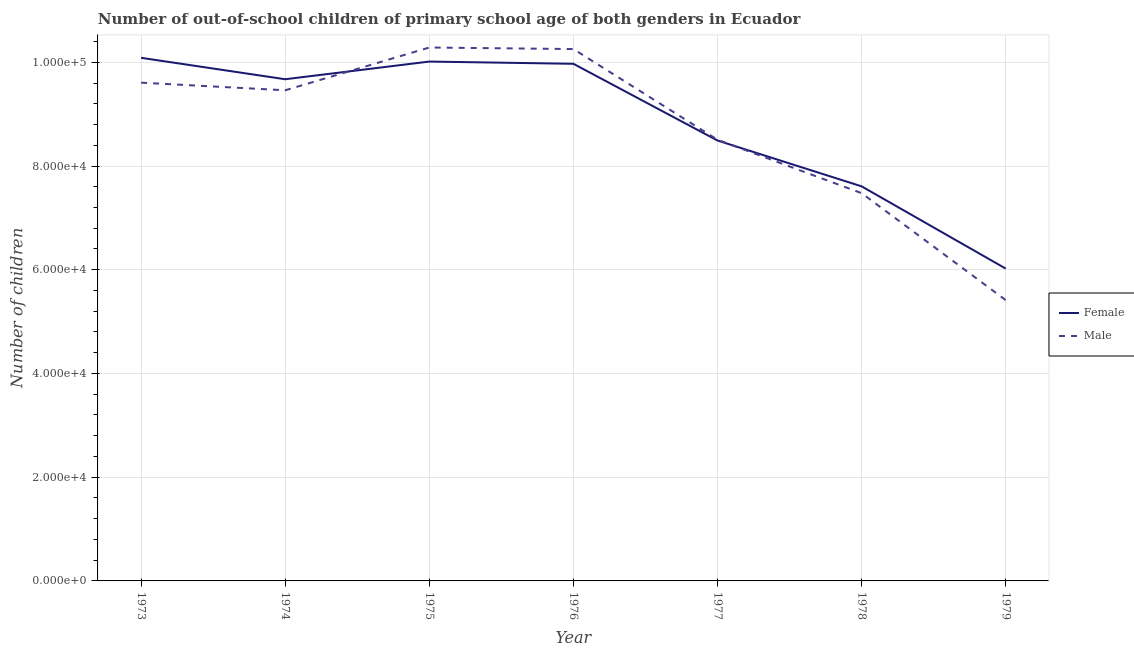Does the line corresponding to number of male out-of-school students intersect with the line corresponding to number of female out-of-school students?
Keep it short and to the point. Yes. What is the number of male out-of-school students in 1974?
Your answer should be very brief. 9.46e+04. Across all years, what is the maximum number of female out-of-school students?
Offer a terse response. 1.01e+05. Across all years, what is the minimum number of male out-of-school students?
Your answer should be compact. 5.41e+04. In which year was the number of female out-of-school students minimum?
Your answer should be very brief. 1979. What is the total number of male out-of-school students in the graph?
Your response must be concise. 6.10e+05. What is the difference between the number of female out-of-school students in 1974 and that in 1975?
Ensure brevity in your answer.  -3409. What is the difference between the number of female out-of-school students in 1974 and the number of male out-of-school students in 1973?
Your response must be concise. 659. What is the average number of male out-of-school students per year?
Offer a very short reply. 8.71e+04. In the year 1975, what is the difference between the number of male out-of-school students and number of female out-of-school students?
Keep it short and to the point. 2709. What is the ratio of the number of female out-of-school students in 1974 to that in 1976?
Offer a terse response. 0.97. What is the difference between the highest and the second highest number of female out-of-school students?
Offer a terse response. 721. What is the difference between the highest and the lowest number of male out-of-school students?
Give a very brief answer. 4.87e+04. Is the sum of the number of female out-of-school students in 1976 and 1977 greater than the maximum number of male out-of-school students across all years?
Ensure brevity in your answer.  Yes. Is the number of female out-of-school students strictly greater than the number of male out-of-school students over the years?
Offer a very short reply. No. Is the number of female out-of-school students strictly less than the number of male out-of-school students over the years?
Your response must be concise. No. How many years are there in the graph?
Keep it short and to the point. 7. What is the difference between two consecutive major ticks on the Y-axis?
Make the answer very short. 2.00e+04. Does the graph contain grids?
Offer a terse response. Yes. Where does the legend appear in the graph?
Keep it short and to the point. Center right. How many legend labels are there?
Keep it short and to the point. 2. What is the title of the graph?
Offer a very short reply. Number of out-of-school children of primary school age of both genders in Ecuador. What is the label or title of the X-axis?
Ensure brevity in your answer.  Year. What is the label or title of the Y-axis?
Offer a terse response. Number of children. What is the Number of children of Female in 1973?
Provide a succinct answer. 1.01e+05. What is the Number of children in Male in 1973?
Ensure brevity in your answer.  9.61e+04. What is the Number of children in Female in 1974?
Offer a very short reply. 9.67e+04. What is the Number of children in Male in 1974?
Offer a terse response. 9.46e+04. What is the Number of children in Female in 1975?
Provide a short and direct response. 1.00e+05. What is the Number of children of Male in 1975?
Keep it short and to the point. 1.03e+05. What is the Number of children in Female in 1976?
Provide a succinct answer. 9.97e+04. What is the Number of children of Male in 1976?
Provide a succinct answer. 1.03e+05. What is the Number of children of Female in 1977?
Provide a succinct answer. 8.49e+04. What is the Number of children in Male in 1977?
Make the answer very short. 8.51e+04. What is the Number of children of Female in 1978?
Provide a succinct answer. 7.61e+04. What is the Number of children in Male in 1978?
Offer a very short reply. 7.48e+04. What is the Number of children in Female in 1979?
Make the answer very short. 6.02e+04. What is the Number of children of Male in 1979?
Your response must be concise. 5.41e+04. Across all years, what is the maximum Number of children in Female?
Ensure brevity in your answer.  1.01e+05. Across all years, what is the maximum Number of children of Male?
Keep it short and to the point. 1.03e+05. Across all years, what is the minimum Number of children in Female?
Your response must be concise. 6.02e+04. Across all years, what is the minimum Number of children in Male?
Make the answer very short. 5.41e+04. What is the total Number of children of Female in the graph?
Provide a succinct answer. 6.19e+05. What is the total Number of children of Male in the graph?
Your response must be concise. 6.10e+05. What is the difference between the Number of children in Female in 1973 and that in 1974?
Offer a terse response. 4130. What is the difference between the Number of children in Male in 1973 and that in 1974?
Your response must be concise. 1470. What is the difference between the Number of children in Female in 1973 and that in 1975?
Keep it short and to the point. 721. What is the difference between the Number of children of Male in 1973 and that in 1975?
Ensure brevity in your answer.  -6777. What is the difference between the Number of children in Female in 1973 and that in 1976?
Make the answer very short. 1154. What is the difference between the Number of children of Male in 1973 and that in 1976?
Your answer should be very brief. -6476. What is the difference between the Number of children in Female in 1973 and that in 1977?
Your response must be concise. 1.60e+04. What is the difference between the Number of children of Male in 1973 and that in 1977?
Offer a terse response. 1.10e+04. What is the difference between the Number of children of Female in 1973 and that in 1978?
Your answer should be very brief. 2.48e+04. What is the difference between the Number of children of Male in 1973 and that in 1978?
Provide a short and direct response. 2.13e+04. What is the difference between the Number of children of Female in 1973 and that in 1979?
Your answer should be compact. 4.06e+04. What is the difference between the Number of children in Male in 1973 and that in 1979?
Provide a succinct answer. 4.19e+04. What is the difference between the Number of children of Female in 1974 and that in 1975?
Offer a terse response. -3409. What is the difference between the Number of children of Male in 1974 and that in 1975?
Ensure brevity in your answer.  -8247. What is the difference between the Number of children in Female in 1974 and that in 1976?
Your response must be concise. -2976. What is the difference between the Number of children in Male in 1974 and that in 1976?
Provide a short and direct response. -7946. What is the difference between the Number of children in Female in 1974 and that in 1977?
Give a very brief answer. 1.18e+04. What is the difference between the Number of children of Male in 1974 and that in 1977?
Make the answer very short. 9545. What is the difference between the Number of children in Female in 1974 and that in 1978?
Make the answer very short. 2.07e+04. What is the difference between the Number of children of Male in 1974 and that in 1978?
Your response must be concise. 1.98e+04. What is the difference between the Number of children of Female in 1974 and that in 1979?
Your response must be concise. 3.65e+04. What is the difference between the Number of children of Male in 1974 and that in 1979?
Your answer should be very brief. 4.05e+04. What is the difference between the Number of children of Female in 1975 and that in 1976?
Offer a terse response. 433. What is the difference between the Number of children in Male in 1975 and that in 1976?
Make the answer very short. 301. What is the difference between the Number of children of Female in 1975 and that in 1977?
Keep it short and to the point. 1.52e+04. What is the difference between the Number of children of Male in 1975 and that in 1977?
Provide a succinct answer. 1.78e+04. What is the difference between the Number of children in Female in 1975 and that in 1978?
Ensure brevity in your answer.  2.41e+04. What is the difference between the Number of children in Male in 1975 and that in 1978?
Your response must be concise. 2.81e+04. What is the difference between the Number of children in Female in 1975 and that in 1979?
Make the answer very short. 3.99e+04. What is the difference between the Number of children of Male in 1975 and that in 1979?
Offer a terse response. 4.87e+04. What is the difference between the Number of children of Female in 1976 and that in 1977?
Keep it short and to the point. 1.48e+04. What is the difference between the Number of children of Male in 1976 and that in 1977?
Ensure brevity in your answer.  1.75e+04. What is the difference between the Number of children in Female in 1976 and that in 1978?
Give a very brief answer. 2.36e+04. What is the difference between the Number of children of Male in 1976 and that in 1978?
Offer a very short reply. 2.78e+04. What is the difference between the Number of children of Female in 1976 and that in 1979?
Make the answer very short. 3.95e+04. What is the difference between the Number of children in Male in 1976 and that in 1979?
Keep it short and to the point. 4.84e+04. What is the difference between the Number of children in Female in 1977 and that in 1978?
Keep it short and to the point. 8834. What is the difference between the Number of children in Male in 1977 and that in 1978?
Offer a very short reply. 1.03e+04. What is the difference between the Number of children of Female in 1977 and that in 1979?
Provide a short and direct response. 2.47e+04. What is the difference between the Number of children of Male in 1977 and that in 1979?
Your answer should be compact. 3.09e+04. What is the difference between the Number of children of Female in 1978 and that in 1979?
Your answer should be very brief. 1.59e+04. What is the difference between the Number of children of Male in 1978 and that in 1979?
Offer a very short reply. 2.06e+04. What is the difference between the Number of children of Female in 1973 and the Number of children of Male in 1974?
Provide a succinct answer. 6259. What is the difference between the Number of children in Female in 1973 and the Number of children in Male in 1975?
Provide a succinct answer. -1988. What is the difference between the Number of children of Female in 1973 and the Number of children of Male in 1976?
Make the answer very short. -1687. What is the difference between the Number of children of Female in 1973 and the Number of children of Male in 1977?
Your answer should be very brief. 1.58e+04. What is the difference between the Number of children of Female in 1973 and the Number of children of Male in 1978?
Your response must be concise. 2.61e+04. What is the difference between the Number of children in Female in 1973 and the Number of children in Male in 1979?
Provide a short and direct response. 4.67e+04. What is the difference between the Number of children in Female in 1974 and the Number of children in Male in 1975?
Give a very brief answer. -6118. What is the difference between the Number of children of Female in 1974 and the Number of children of Male in 1976?
Offer a very short reply. -5817. What is the difference between the Number of children in Female in 1974 and the Number of children in Male in 1977?
Give a very brief answer. 1.17e+04. What is the difference between the Number of children of Female in 1974 and the Number of children of Male in 1978?
Provide a succinct answer. 2.20e+04. What is the difference between the Number of children of Female in 1974 and the Number of children of Male in 1979?
Your response must be concise. 4.26e+04. What is the difference between the Number of children in Female in 1975 and the Number of children in Male in 1976?
Offer a very short reply. -2408. What is the difference between the Number of children of Female in 1975 and the Number of children of Male in 1977?
Your answer should be very brief. 1.51e+04. What is the difference between the Number of children in Female in 1975 and the Number of children in Male in 1978?
Make the answer very short. 2.54e+04. What is the difference between the Number of children of Female in 1975 and the Number of children of Male in 1979?
Offer a terse response. 4.60e+04. What is the difference between the Number of children in Female in 1976 and the Number of children in Male in 1977?
Keep it short and to the point. 1.46e+04. What is the difference between the Number of children in Female in 1976 and the Number of children in Male in 1978?
Provide a succinct answer. 2.49e+04. What is the difference between the Number of children in Female in 1976 and the Number of children in Male in 1979?
Give a very brief answer. 4.56e+04. What is the difference between the Number of children in Female in 1977 and the Number of children in Male in 1978?
Your response must be concise. 1.01e+04. What is the difference between the Number of children of Female in 1977 and the Number of children of Male in 1979?
Keep it short and to the point. 3.08e+04. What is the difference between the Number of children of Female in 1978 and the Number of children of Male in 1979?
Your answer should be compact. 2.19e+04. What is the average Number of children of Female per year?
Offer a terse response. 8.84e+04. What is the average Number of children of Male per year?
Offer a terse response. 8.71e+04. In the year 1973, what is the difference between the Number of children in Female and Number of children in Male?
Make the answer very short. 4789. In the year 1974, what is the difference between the Number of children of Female and Number of children of Male?
Your response must be concise. 2129. In the year 1975, what is the difference between the Number of children in Female and Number of children in Male?
Provide a succinct answer. -2709. In the year 1976, what is the difference between the Number of children of Female and Number of children of Male?
Ensure brevity in your answer.  -2841. In the year 1977, what is the difference between the Number of children in Female and Number of children in Male?
Offer a very short reply. -146. In the year 1978, what is the difference between the Number of children of Female and Number of children of Male?
Ensure brevity in your answer.  1313. In the year 1979, what is the difference between the Number of children of Female and Number of children of Male?
Make the answer very short. 6079. What is the ratio of the Number of children in Female in 1973 to that in 1974?
Your answer should be very brief. 1.04. What is the ratio of the Number of children in Male in 1973 to that in 1974?
Your response must be concise. 1.02. What is the ratio of the Number of children of Female in 1973 to that in 1975?
Provide a succinct answer. 1.01. What is the ratio of the Number of children in Male in 1973 to that in 1975?
Your response must be concise. 0.93. What is the ratio of the Number of children in Female in 1973 to that in 1976?
Your response must be concise. 1.01. What is the ratio of the Number of children in Male in 1973 to that in 1976?
Your response must be concise. 0.94. What is the ratio of the Number of children of Female in 1973 to that in 1977?
Offer a very short reply. 1.19. What is the ratio of the Number of children of Male in 1973 to that in 1977?
Provide a succinct answer. 1.13. What is the ratio of the Number of children of Female in 1973 to that in 1978?
Ensure brevity in your answer.  1.33. What is the ratio of the Number of children in Male in 1973 to that in 1978?
Provide a succinct answer. 1.28. What is the ratio of the Number of children of Female in 1973 to that in 1979?
Make the answer very short. 1.68. What is the ratio of the Number of children of Male in 1973 to that in 1979?
Make the answer very short. 1.77. What is the ratio of the Number of children of Female in 1974 to that in 1975?
Give a very brief answer. 0.97. What is the ratio of the Number of children in Male in 1974 to that in 1975?
Provide a short and direct response. 0.92. What is the ratio of the Number of children in Female in 1974 to that in 1976?
Provide a succinct answer. 0.97. What is the ratio of the Number of children of Male in 1974 to that in 1976?
Ensure brevity in your answer.  0.92. What is the ratio of the Number of children in Female in 1974 to that in 1977?
Provide a succinct answer. 1.14. What is the ratio of the Number of children of Male in 1974 to that in 1977?
Your answer should be very brief. 1.11. What is the ratio of the Number of children of Female in 1974 to that in 1978?
Your answer should be very brief. 1.27. What is the ratio of the Number of children in Male in 1974 to that in 1978?
Your answer should be very brief. 1.27. What is the ratio of the Number of children in Female in 1974 to that in 1979?
Provide a short and direct response. 1.61. What is the ratio of the Number of children in Male in 1974 to that in 1979?
Ensure brevity in your answer.  1.75. What is the ratio of the Number of children of Female in 1975 to that in 1977?
Offer a very short reply. 1.18. What is the ratio of the Number of children in Male in 1975 to that in 1977?
Make the answer very short. 1.21. What is the ratio of the Number of children in Female in 1975 to that in 1978?
Your answer should be very brief. 1.32. What is the ratio of the Number of children in Male in 1975 to that in 1978?
Provide a succinct answer. 1.38. What is the ratio of the Number of children in Female in 1975 to that in 1979?
Give a very brief answer. 1.66. What is the ratio of the Number of children of Male in 1975 to that in 1979?
Provide a short and direct response. 1.9. What is the ratio of the Number of children in Female in 1976 to that in 1977?
Provide a succinct answer. 1.17. What is the ratio of the Number of children in Male in 1976 to that in 1977?
Give a very brief answer. 1.21. What is the ratio of the Number of children in Female in 1976 to that in 1978?
Provide a short and direct response. 1.31. What is the ratio of the Number of children of Male in 1976 to that in 1978?
Keep it short and to the point. 1.37. What is the ratio of the Number of children in Female in 1976 to that in 1979?
Your answer should be compact. 1.66. What is the ratio of the Number of children of Male in 1976 to that in 1979?
Offer a terse response. 1.89. What is the ratio of the Number of children of Female in 1977 to that in 1978?
Offer a terse response. 1.12. What is the ratio of the Number of children of Male in 1977 to that in 1978?
Your answer should be compact. 1.14. What is the ratio of the Number of children of Female in 1977 to that in 1979?
Ensure brevity in your answer.  1.41. What is the ratio of the Number of children of Male in 1977 to that in 1979?
Give a very brief answer. 1.57. What is the ratio of the Number of children in Female in 1978 to that in 1979?
Your answer should be very brief. 1.26. What is the ratio of the Number of children in Male in 1978 to that in 1979?
Make the answer very short. 1.38. What is the difference between the highest and the second highest Number of children of Female?
Offer a very short reply. 721. What is the difference between the highest and the second highest Number of children in Male?
Ensure brevity in your answer.  301. What is the difference between the highest and the lowest Number of children in Female?
Offer a very short reply. 4.06e+04. What is the difference between the highest and the lowest Number of children in Male?
Give a very brief answer. 4.87e+04. 